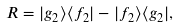Convert formula to latex. <formula><loc_0><loc_0><loc_500><loc_500>R = | g _ { 2 } \rangle \langle f _ { 2 } | - | f _ { 2 } \rangle \langle g _ { 2 } | ,</formula> 